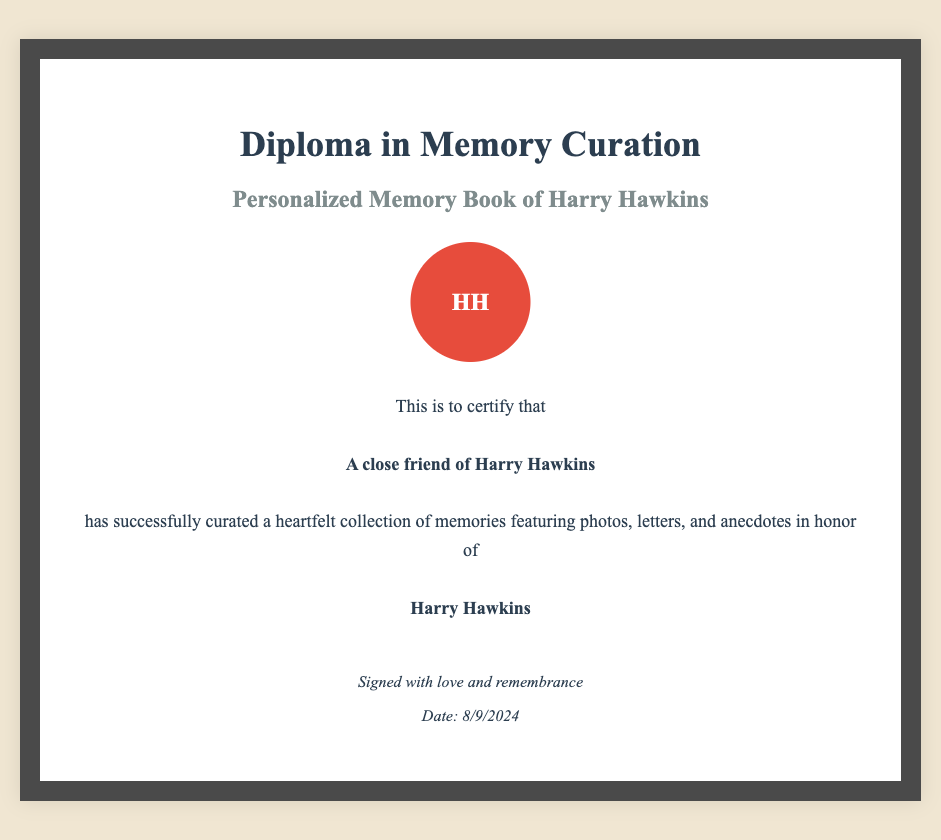What is the title of the diploma? The title is clearly stated at the top of the document, which identifies the qualification awarded.
Answer: Diploma in Memory Curation Who is the certificate for? The document specifies the recipient of the certificate, indicated in a bold font.
Answer: A close friend of Harry Hawkins What is being honored in this diploma? The diploma describes the purpose of the award related to the subject of the memory book.
Answer: Harry Hawkins What type of collection is being certified? The document describes the nature of the curated work, indicating its essence and contents.
Answer: A heartfelt collection of memories What does the seal on the diploma represent? The seal typically symbolizes the authenticity or significance of the document, here represented by initials.
Answer: HH What is included in the memory book? The content of the memory book is specifically mentioned in the document, highlighting its various components.
Answer: Photos, letters, and anecdotes What can be inferred about the relationship between the recipient and Harry Hawkins? The language used in the document reflects the emotional connection between the parties involved.
Answer: Close friend When will the diploma be dated? The date is dynamically generated in the document, reflecting the current date when viewed.
Answer: Current date 